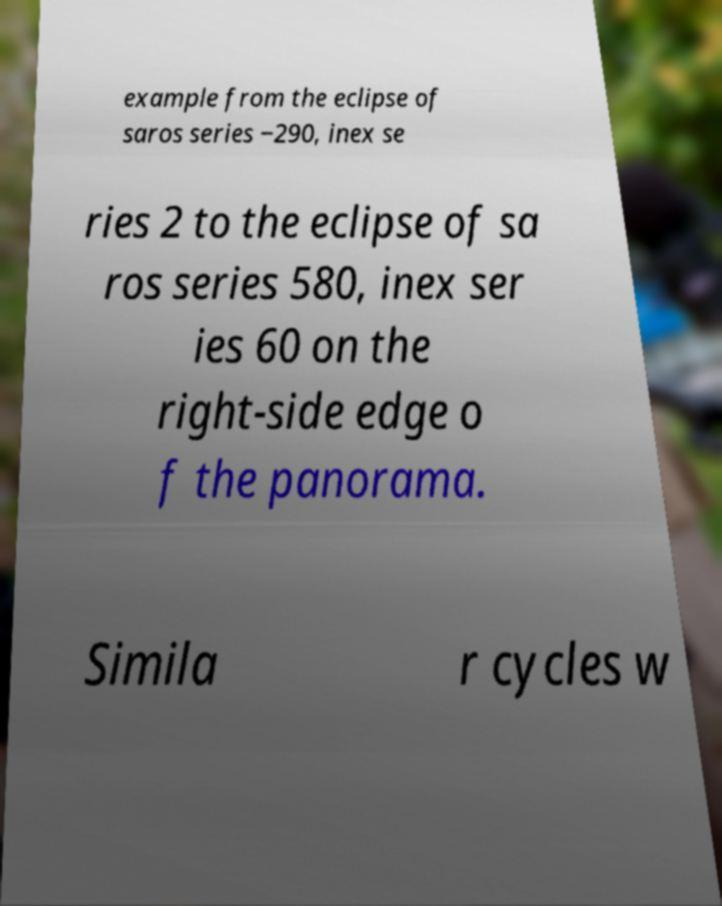I need the written content from this picture converted into text. Can you do that? example from the eclipse of saros series −290, inex se ries 2 to the eclipse of sa ros series 580, inex ser ies 60 on the right-side edge o f the panorama. Simila r cycles w 